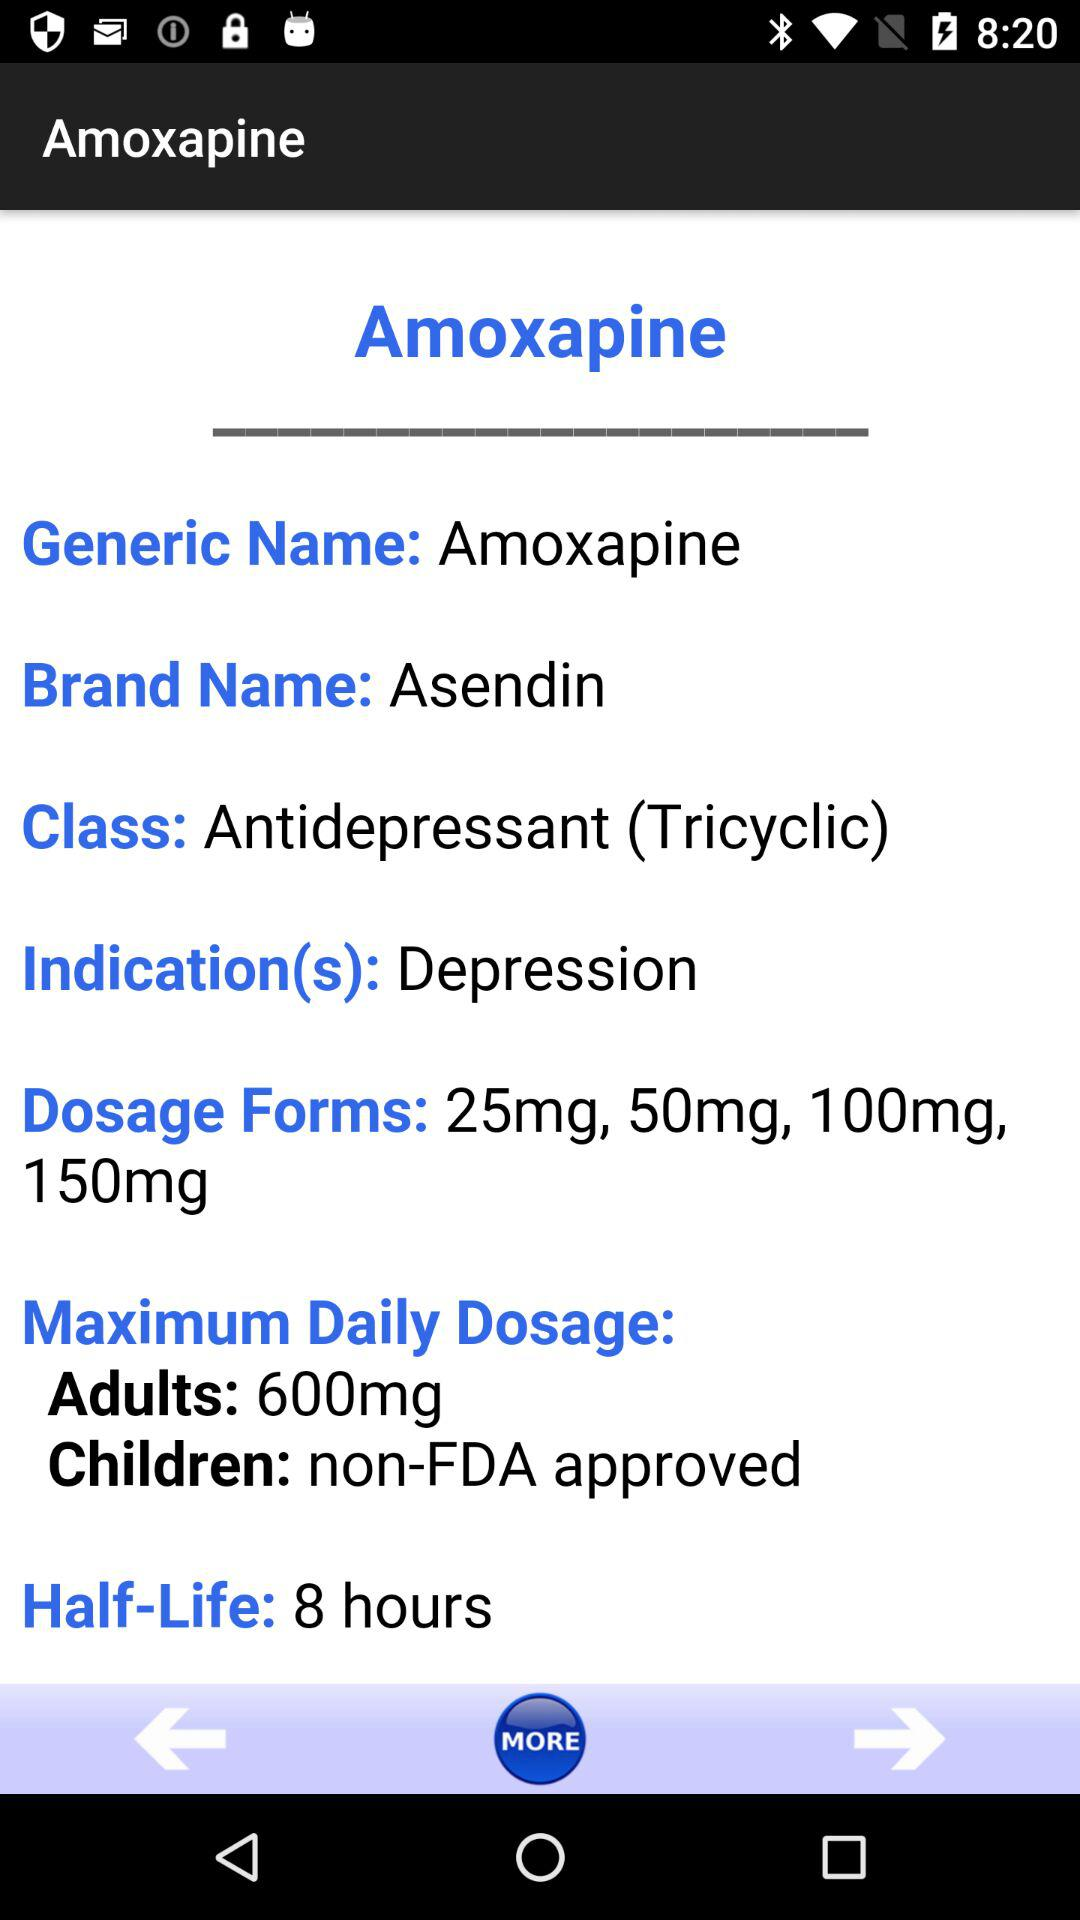How many dosage forms are available for Amoxapine?
Answer the question using a single word or phrase. 4 